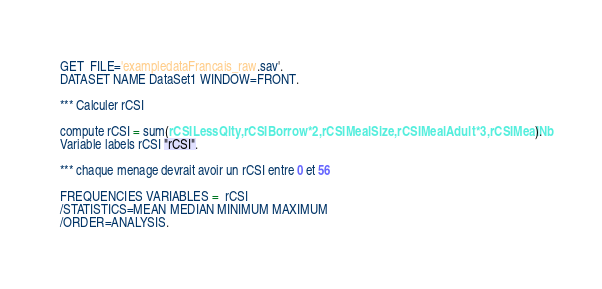Convert code to text. <code><loc_0><loc_0><loc_500><loc_500><_Scheme_>GET  FILE='exampledataFrancais_raw.sav'.
DATASET NAME DataSet1 WINDOW=FRONT.

*** Calculer rCSI

compute rCSI = sum(rCSILessQlty,rCSIBorrow*2,rCSIMealSize,rCSIMealAdult*3,rCSIMealNb).
Variable labels rCSI "rCSI".

*** chaque menage devrait avoir un rCSI entre 0 et 56

FREQUENCIES VARIABLES =  rCSI
/STATISTICS=MEAN MEDIAN MINIMUM MAXIMUM
/ORDER=ANALYSIS.
</code> 